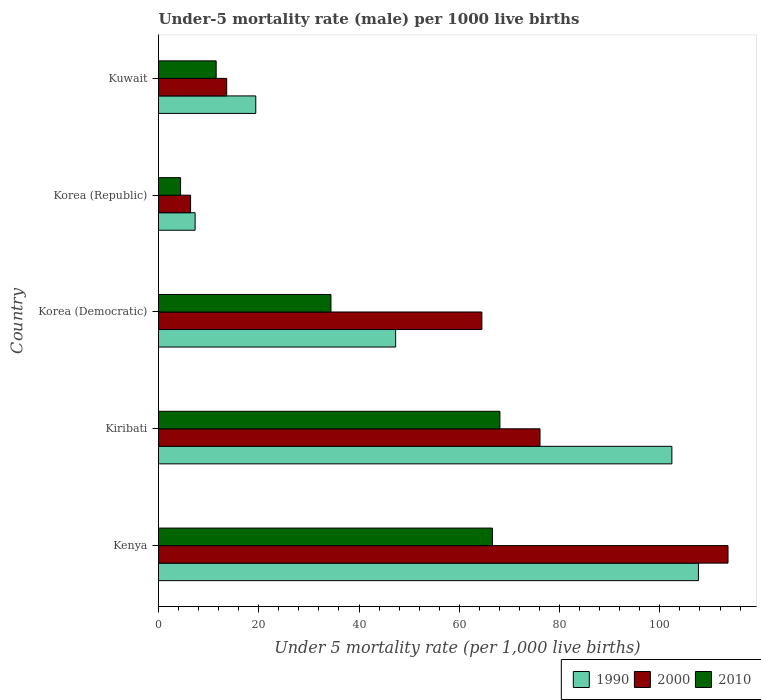How many groups of bars are there?
Provide a succinct answer. 5. Are the number of bars per tick equal to the number of legend labels?
Provide a short and direct response. Yes. Are the number of bars on each tick of the Y-axis equal?
Your answer should be very brief. Yes. How many bars are there on the 5th tick from the bottom?
Keep it short and to the point. 3. What is the label of the 1st group of bars from the top?
Offer a terse response. Kuwait. In how many cases, is the number of bars for a given country not equal to the number of legend labels?
Provide a succinct answer. 0. What is the under-five mortality rate in 1990 in Kiribati?
Offer a very short reply. 102.4. Across all countries, what is the maximum under-five mortality rate in 1990?
Provide a short and direct response. 107.7. Across all countries, what is the minimum under-five mortality rate in 2000?
Your answer should be very brief. 6.4. In which country was the under-five mortality rate in 2000 maximum?
Your answer should be very brief. Kenya. In which country was the under-five mortality rate in 1990 minimum?
Provide a succinct answer. Korea (Republic). What is the total under-five mortality rate in 2010 in the graph?
Give a very brief answer. 185. What is the difference between the under-five mortality rate in 2000 in Kenya and that in Korea (Democratic)?
Your answer should be very brief. 49.1. What is the difference between the under-five mortality rate in 1990 in Korea (Democratic) and the under-five mortality rate in 2000 in Korea (Republic)?
Your answer should be very brief. 40.9. What is the average under-five mortality rate in 2000 per country?
Keep it short and to the point. 54.84. What is the difference between the under-five mortality rate in 2010 and under-five mortality rate in 1990 in Kenya?
Give a very brief answer. -41.1. In how many countries, is the under-five mortality rate in 2000 greater than 88 ?
Offer a very short reply. 1. What is the ratio of the under-five mortality rate in 1990 in Kiribati to that in Korea (Republic)?
Give a very brief answer. 14.03. Is the difference between the under-five mortality rate in 2010 in Korea (Democratic) and Korea (Republic) greater than the difference between the under-five mortality rate in 1990 in Korea (Democratic) and Korea (Republic)?
Provide a short and direct response. No. What is the difference between the highest and the second highest under-five mortality rate in 2010?
Ensure brevity in your answer.  1.5. What is the difference between the highest and the lowest under-five mortality rate in 2010?
Your answer should be very brief. 63.7. What does the 3rd bar from the top in Korea (Democratic) represents?
Your response must be concise. 1990. How many bars are there?
Your answer should be compact. 15. How many countries are there in the graph?
Offer a terse response. 5. What is the difference between two consecutive major ticks on the X-axis?
Provide a short and direct response. 20. Does the graph contain grids?
Provide a succinct answer. No. What is the title of the graph?
Keep it short and to the point. Under-5 mortality rate (male) per 1000 live births. Does "1964" appear as one of the legend labels in the graph?
Give a very brief answer. No. What is the label or title of the X-axis?
Keep it short and to the point. Under 5 mortality rate (per 1,0 live births). What is the label or title of the Y-axis?
Offer a terse response. Country. What is the Under 5 mortality rate (per 1,000 live births) of 1990 in Kenya?
Your response must be concise. 107.7. What is the Under 5 mortality rate (per 1,000 live births) of 2000 in Kenya?
Offer a very short reply. 113.6. What is the Under 5 mortality rate (per 1,000 live births) of 2010 in Kenya?
Your answer should be very brief. 66.6. What is the Under 5 mortality rate (per 1,000 live births) in 1990 in Kiribati?
Give a very brief answer. 102.4. What is the Under 5 mortality rate (per 1,000 live births) in 2000 in Kiribati?
Your response must be concise. 76.1. What is the Under 5 mortality rate (per 1,000 live births) of 2010 in Kiribati?
Provide a succinct answer. 68.1. What is the Under 5 mortality rate (per 1,000 live births) in 1990 in Korea (Democratic)?
Your answer should be compact. 47.3. What is the Under 5 mortality rate (per 1,000 live births) of 2000 in Korea (Democratic)?
Offer a terse response. 64.5. What is the Under 5 mortality rate (per 1,000 live births) of 2010 in Korea (Democratic)?
Make the answer very short. 34.4. What is the Under 5 mortality rate (per 1,000 live births) in 2000 in Korea (Republic)?
Offer a terse response. 6.4. What is the Under 5 mortality rate (per 1,000 live births) in 2010 in Korea (Republic)?
Keep it short and to the point. 4.4. What is the Under 5 mortality rate (per 1,000 live births) in 1990 in Kuwait?
Provide a succinct answer. 19.4. What is the Under 5 mortality rate (per 1,000 live births) of 2000 in Kuwait?
Provide a succinct answer. 13.6. Across all countries, what is the maximum Under 5 mortality rate (per 1,000 live births) in 1990?
Provide a short and direct response. 107.7. Across all countries, what is the maximum Under 5 mortality rate (per 1,000 live births) of 2000?
Provide a succinct answer. 113.6. Across all countries, what is the maximum Under 5 mortality rate (per 1,000 live births) in 2010?
Offer a terse response. 68.1. Across all countries, what is the minimum Under 5 mortality rate (per 1,000 live births) in 1990?
Offer a terse response. 7.3. Across all countries, what is the minimum Under 5 mortality rate (per 1,000 live births) of 2000?
Ensure brevity in your answer.  6.4. What is the total Under 5 mortality rate (per 1,000 live births) in 1990 in the graph?
Offer a terse response. 284.1. What is the total Under 5 mortality rate (per 1,000 live births) in 2000 in the graph?
Provide a short and direct response. 274.2. What is the total Under 5 mortality rate (per 1,000 live births) of 2010 in the graph?
Make the answer very short. 185. What is the difference between the Under 5 mortality rate (per 1,000 live births) in 2000 in Kenya and that in Kiribati?
Keep it short and to the point. 37.5. What is the difference between the Under 5 mortality rate (per 1,000 live births) of 2010 in Kenya and that in Kiribati?
Ensure brevity in your answer.  -1.5. What is the difference between the Under 5 mortality rate (per 1,000 live births) of 1990 in Kenya and that in Korea (Democratic)?
Your response must be concise. 60.4. What is the difference between the Under 5 mortality rate (per 1,000 live births) in 2000 in Kenya and that in Korea (Democratic)?
Your answer should be compact. 49.1. What is the difference between the Under 5 mortality rate (per 1,000 live births) of 2010 in Kenya and that in Korea (Democratic)?
Make the answer very short. 32.2. What is the difference between the Under 5 mortality rate (per 1,000 live births) in 1990 in Kenya and that in Korea (Republic)?
Keep it short and to the point. 100.4. What is the difference between the Under 5 mortality rate (per 1,000 live births) of 2000 in Kenya and that in Korea (Republic)?
Provide a succinct answer. 107.2. What is the difference between the Under 5 mortality rate (per 1,000 live births) in 2010 in Kenya and that in Korea (Republic)?
Make the answer very short. 62.2. What is the difference between the Under 5 mortality rate (per 1,000 live births) in 1990 in Kenya and that in Kuwait?
Ensure brevity in your answer.  88.3. What is the difference between the Under 5 mortality rate (per 1,000 live births) in 2010 in Kenya and that in Kuwait?
Offer a very short reply. 55.1. What is the difference between the Under 5 mortality rate (per 1,000 live births) in 1990 in Kiribati and that in Korea (Democratic)?
Give a very brief answer. 55.1. What is the difference between the Under 5 mortality rate (per 1,000 live births) of 2000 in Kiribati and that in Korea (Democratic)?
Keep it short and to the point. 11.6. What is the difference between the Under 5 mortality rate (per 1,000 live births) of 2010 in Kiribati and that in Korea (Democratic)?
Provide a short and direct response. 33.7. What is the difference between the Under 5 mortality rate (per 1,000 live births) in 1990 in Kiribati and that in Korea (Republic)?
Your answer should be compact. 95.1. What is the difference between the Under 5 mortality rate (per 1,000 live births) in 2000 in Kiribati and that in Korea (Republic)?
Your answer should be compact. 69.7. What is the difference between the Under 5 mortality rate (per 1,000 live births) in 2010 in Kiribati and that in Korea (Republic)?
Ensure brevity in your answer.  63.7. What is the difference between the Under 5 mortality rate (per 1,000 live births) in 1990 in Kiribati and that in Kuwait?
Give a very brief answer. 83. What is the difference between the Under 5 mortality rate (per 1,000 live births) in 2000 in Kiribati and that in Kuwait?
Keep it short and to the point. 62.5. What is the difference between the Under 5 mortality rate (per 1,000 live births) in 2010 in Kiribati and that in Kuwait?
Ensure brevity in your answer.  56.6. What is the difference between the Under 5 mortality rate (per 1,000 live births) of 1990 in Korea (Democratic) and that in Korea (Republic)?
Provide a succinct answer. 40. What is the difference between the Under 5 mortality rate (per 1,000 live births) of 2000 in Korea (Democratic) and that in Korea (Republic)?
Your answer should be very brief. 58.1. What is the difference between the Under 5 mortality rate (per 1,000 live births) in 2010 in Korea (Democratic) and that in Korea (Republic)?
Ensure brevity in your answer.  30. What is the difference between the Under 5 mortality rate (per 1,000 live births) of 1990 in Korea (Democratic) and that in Kuwait?
Your response must be concise. 27.9. What is the difference between the Under 5 mortality rate (per 1,000 live births) in 2000 in Korea (Democratic) and that in Kuwait?
Make the answer very short. 50.9. What is the difference between the Under 5 mortality rate (per 1,000 live births) of 2010 in Korea (Democratic) and that in Kuwait?
Keep it short and to the point. 22.9. What is the difference between the Under 5 mortality rate (per 1,000 live births) of 1990 in Korea (Republic) and that in Kuwait?
Make the answer very short. -12.1. What is the difference between the Under 5 mortality rate (per 1,000 live births) in 2000 in Korea (Republic) and that in Kuwait?
Give a very brief answer. -7.2. What is the difference between the Under 5 mortality rate (per 1,000 live births) in 1990 in Kenya and the Under 5 mortality rate (per 1,000 live births) in 2000 in Kiribati?
Your answer should be compact. 31.6. What is the difference between the Under 5 mortality rate (per 1,000 live births) of 1990 in Kenya and the Under 5 mortality rate (per 1,000 live births) of 2010 in Kiribati?
Your answer should be compact. 39.6. What is the difference between the Under 5 mortality rate (per 1,000 live births) in 2000 in Kenya and the Under 5 mortality rate (per 1,000 live births) in 2010 in Kiribati?
Your response must be concise. 45.5. What is the difference between the Under 5 mortality rate (per 1,000 live births) of 1990 in Kenya and the Under 5 mortality rate (per 1,000 live births) of 2000 in Korea (Democratic)?
Give a very brief answer. 43.2. What is the difference between the Under 5 mortality rate (per 1,000 live births) in 1990 in Kenya and the Under 5 mortality rate (per 1,000 live births) in 2010 in Korea (Democratic)?
Offer a terse response. 73.3. What is the difference between the Under 5 mortality rate (per 1,000 live births) in 2000 in Kenya and the Under 5 mortality rate (per 1,000 live births) in 2010 in Korea (Democratic)?
Provide a short and direct response. 79.2. What is the difference between the Under 5 mortality rate (per 1,000 live births) in 1990 in Kenya and the Under 5 mortality rate (per 1,000 live births) in 2000 in Korea (Republic)?
Ensure brevity in your answer.  101.3. What is the difference between the Under 5 mortality rate (per 1,000 live births) of 1990 in Kenya and the Under 5 mortality rate (per 1,000 live births) of 2010 in Korea (Republic)?
Provide a short and direct response. 103.3. What is the difference between the Under 5 mortality rate (per 1,000 live births) of 2000 in Kenya and the Under 5 mortality rate (per 1,000 live births) of 2010 in Korea (Republic)?
Provide a succinct answer. 109.2. What is the difference between the Under 5 mortality rate (per 1,000 live births) in 1990 in Kenya and the Under 5 mortality rate (per 1,000 live births) in 2000 in Kuwait?
Give a very brief answer. 94.1. What is the difference between the Under 5 mortality rate (per 1,000 live births) in 1990 in Kenya and the Under 5 mortality rate (per 1,000 live births) in 2010 in Kuwait?
Your answer should be very brief. 96.2. What is the difference between the Under 5 mortality rate (per 1,000 live births) of 2000 in Kenya and the Under 5 mortality rate (per 1,000 live births) of 2010 in Kuwait?
Give a very brief answer. 102.1. What is the difference between the Under 5 mortality rate (per 1,000 live births) in 1990 in Kiribati and the Under 5 mortality rate (per 1,000 live births) in 2000 in Korea (Democratic)?
Give a very brief answer. 37.9. What is the difference between the Under 5 mortality rate (per 1,000 live births) of 1990 in Kiribati and the Under 5 mortality rate (per 1,000 live births) of 2010 in Korea (Democratic)?
Ensure brevity in your answer.  68. What is the difference between the Under 5 mortality rate (per 1,000 live births) of 2000 in Kiribati and the Under 5 mortality rate (per 1,000 live births) of 2010 in Korea (Democratic)?
Offer a terse response. 41.7. What is the difference between the Under 5 mortality rate (per 1,000 live births) of 1990 in Kiribati and the Under 5 mortality rate (per 1,000 live births) of 2000 in Korea (Republic)?
Your response must be concise. 96. What is the difference between the Under 5 mortality rate (per 1,000 live births) of 2000 in Kiribati and the Under 5 mortality rate (per 1,000 live births) of 2010 in Korea (Republic)?
Give a very brief answer. 71.7. What is the difference between the Under 5 mortality rate (per 1,000 live births) in 1990 in Kiribati and the Under 5 mortality rate (per 1,000 live births) in 2000 in Kuwait?
Your answer should be compact. 88.8. What is the difference between the Under 5 mortality rate (per 1,000 live births) in 1990 in Kiribati and the Under 5 mortality rate (per 1,000 live births) in 2010 in Kuwait?
Provide a short and direct response. 90.9. What is the difference between the Under 5 mortality rate (per 1,000 live births) of 2000 in Kiribati and the Under 5 mortality rate (per 1,000 live births) of 2010 in Kuwait?
Provide a short and direct response. 64.6. What is the difference between the Under 5 mortality rate (per 1,000 live births) in 1990 in Korea (Democratic) and the Under 5 mortality rate (per 1,000 live births) in 2000 in Korea (Republic)?
Provide a succinct answer. 40.9. What is the difference between the Under 5 mortality rate (per 1,000 live births) in 1990 in Korea (Democratic) and the Under 5 mortality rate (per 1,000 live births) in 2010 in Korea (Republic)?
Offer a terse response. 42.9. What is the difference between the Under 5 mortality rate (per 1,000 live births) in 2000 in Korea (Democratic) and the Under 5 mortality rate (per 1,000 live births) in 2010 in Korea (Republic)?
Offer a very short reply. 60.1. What is the difference between the Under 5 mortality rate (per 1,000 live births) of 1990 in Korea (Democratic) and the Under 5 mortality rate (per 1,000 live births) of 2000 in Kuwait?
Ensure brevity in your answer.  33.7. What is the difference between the Under 5 mortality rate (per 1,000 live births) in 1990 in Korea (Democratic) and the Under 5 mortality rate (per 1,000 live births) in 2010 in Kuwait?
Offer a very short reply. 35.8. What is the difference between the Under 5 mortality rate (per 1,000 live births) of 2000 in Korea (Democratic) and the Under 5 mortality rate (per 1,000 live births) of 2010 in Kuwait?
Your answer should be compact. 53. What is the average Under 5 mortality rate (per 1,000 live births) in 1990 per country?
Provide a short and direct response. 56.82. What is the average Under 5 mortality rate (per 1,000 live births) in 2000 per country?
Your answer should be compact. 54.84. What is the difference between the Under 5 mortality rate (per 1,000 live births) of 1990 and Under 5 mortality rate (per 1,000 live births) of 2000 in Kenya?
Offer a very short reply. -5.9. What is the difference between the Under 5 mortality rate (per 1,000 live births) in 1990 and Under 5 mortality rate (per 1,000 live births) in 2010 in Kenya?
Offer a very short reply. 41.1. What is the difference between the Under 5 mortality rate (per 1,000 live births) of 2000 and Under 5 mortality rate (per 1,000 live births) of 2010 in Kenya?
Keep it short and to the point. 47. What is the difference between the Under 5 mortality rate (per 1,000 live births) in 1990 and Under 5 mortality rate (per 1,000 live births) in 2000 in Kiribati?
Ensure brevity in your answer.  26.3. What is the difference between the Under 5 mortality rate (per 1,000 live births) of 1990 and Under 5 mortality rate (per 1,000 live births) of 2010 in Kiribati?
Provide a short and direct response. 34.3. What is the difference between the Under 5 mortality rate (per 1,000 live births) in 1990 and Under 5 mortality rate (per 1,000 live births) in 2000 in Korea (Democratic)?
Your response must be concise. -17.2. What is the difference between the Under 5 mortality rate (per 1,000 live births) in 2000 and Under 5 mortality rate (per 1,000 live births) in 2010 in Korea (Democratic)?
Keep it short and to the point. 30.1. What is the difference between the Under 5 mortality rate (per 1,000 live births) of 1990 and Under 5 mortality rate (per 1,000 live births) of 2000 in Korea (Republic)?
Your answer should be very brief. 0.9. What is the difference between the Under 5 mortality rate (per 1,000 live births) in 1990 and Under 5 mortality rate (per 1,000 live births) in 2010 in Korea (Republic)?
Give a very brief answer. 2.9. What is the difference between the Under 5 mortality rate (per 1,000 live births) in 2000 and Under 5 mortality rate (per 1,000 live births) in 2010 in Korea (Republic)?
Offer a terse response. 2. What is the difference between the Under 5 mortality rate (per 1,000 live births) in 2000 and Under 5 mortality rate (per 1,000 live births) in 2010 in Kuwait?
Your answer should be compact. 2.1. What is the ratio of the Under 5 mortality rate (per 1,000 live births) in 1990 in Kenya to that in Kiribati?
Provide a succinct answer. 1.05. What is the ratio of the Under 5 mortality rate (per 1,000 live births) in 2000 in Kenya to that in Kiribati?
Offer a terse response. 1.49. What is the ratio of the Under 5 mortality rate (per 1,000 live births) in 1990 in Kenya to that in Korea (Democratic)?
Your answer should be very brief. 2.28. What is the ratio of the Under 5 mortality rate (per 1,000 live births) in 2000 in Kenya to that in Korea (Democratic)?
Give a very brief answer. 1.76. What is the ratio of the Under 5 mortality rate (per 1,000 live births) in 2010 in Kenya to that in Korea (Democratic)?
Your response must be concise. 1.94. What is the ratio of the Under 5 mortality rate (per 1,000 live births) in 1990 in Kenya to that in Korea (Republic)?
Make the answer very short. 14.75. What is the ratio of the Under 5 mortality rate (per 1,000 live births) of 2000 in Kenya to that in Korea (Republic)?
Your answer should be very brief. 17.75. What is the ratio of the Under 5 mortality rate (per 1,000 live births) in 2010 in Kenya to that in Korea (Republic)?
Offer a very short reply. 15.14. What is the ratio of the Under 5 mortality rate (per 1,000 live births) in 1990 in Kenya to that in Kuwait?
Offer a terse response. 5.55. What is the ratio of the Under 5 mortality rate (per 1,000 live births) in 2000 in Kenya to that in Kuwait?
Offer a very short reply. 8.35. What is the ratio of the Under 5 mortality rate (per 1,000 live births) in 2010 in Kenya to that in Kuwait?
Offer a terse response. 5.79. What is the ratio of the Under 5 mortality rate (per 1,000 live births) in 1990 in Kiribati to that in Korea (Democratic)?
Your answer should be very brief. 2.16. What is the ratio of the Under 5 mortality rate (per 1,000 live births) in 2000 in Kiribati to that in Korea (Democratic)?
Your answer should be compact. 1.18. What is the ratio of the Under 5 mortality rate (per 1,000 live births) in 2010 in Kiribati to that in Korea (Democratic)?
Make the answer very short. 1.98. What is the ratio of the Under 5 mortality rate (per 1,000 live births) of 1990 in Kiribati to that in Korea (Republic)?
Offer a terse response. 14.03. What is the ratio of the Under 5 mortality rate (per 1,000 live births) of 2000 in Kiribati to that in Korea (Republic)?
Provide a succinct answer. 11.89. What is the ratio of the Under 5 mortality rate (per 1,000 live births) of 2010 in Kiribati to that in Korea (Republic)?
Provide a short and direct response. 15.48. What is the ratio of the Under 5 mortality rate (per 1,000 live births) of 1990 in Kiribati to that in Kuwait?
Your answer should be very brief. 5.28. What is the ratio of the Under 5 mortality rate (per 1,000 live births) in 2000 in Kiribati to that in Kuwait?
Provide a succinct answer. 5.6. What is the ratio of the Under 5 mortality rate (per 1,000 live births) of 2010 in Kiribati to that in Kuwait?
Give a very brief answer. 5.92. What is the ratio of the Under 5 mortality rate (per 1,000 live births) of 1990 in Korea (Democratic) to that in Korea (Republic)?
Ensure brevity in your answer.  6.48. What is the ratio of the Under 5 mortality rate (per 1,000 live births) of 2000 in Korea (Democratic) to that in Korea (Republic)?
Your answer should be compact. 10.08. What is the ratio of the Under 5 mortality rate (per 1,000 live births) in 2010 in Korea (Democratic) to that in Korea (Republic)?
Provide a succinct answer. 7.82. What is the ratio of the Under 5 mortality rate (per 1,000 live births) of 1990 in Korea (Democratic) to that in Kuwait?
Keep it short and to the point. 2.44. What is the ratio of the Under 5 mortality rate (per 1,000 live births) in 2000 in Korea (Democratic) to that in Kuwait?
Make the answer very short. 4.74. What is the ratio of the Under 5 mortality rate (per 1,000 live births) in 2010 in Korea (Democratic) to that in Kuwait?
Provide a succinct answer. 2.99. What is the ratio of the Under 5 mortality rate (per 1,000 live births) in 1990 in Korea (Republic) to that in Kuwait?
Offer a terse response. 0.38. What is the ratio of the Under 5 mortality rate (per 1,000 live births) of 2000 in Korea (Republic) to that in Kuwait?
Make the answer very short. 0.47. What is the ratio of the Under 5 mortality rate (per 1,000 live births) in 2010 in Korea (Republic) to that in Kuwait?
Offer a terse response. 0.38. What is the difference between the highest and the second highest Under 5 mortality rate (per 1,000 live births) in 2000?
Provide a succinct answer. 37.5. What is the difference between the highest and the lowest Under 5 mortality rate (per 1,000 live births) of 1990?
Provide a short and direct response. 100.4. What is the difference between the highest and the lowest Under 5 mortality rate (per 1,000 live births) in 2000?
Your answer should be very brief. 107.2. What is the difference between the highest and the lowest Under 5 mortality rate (per 1,000 live births) of 2010?
Keep it short and to the point. 63.7. 